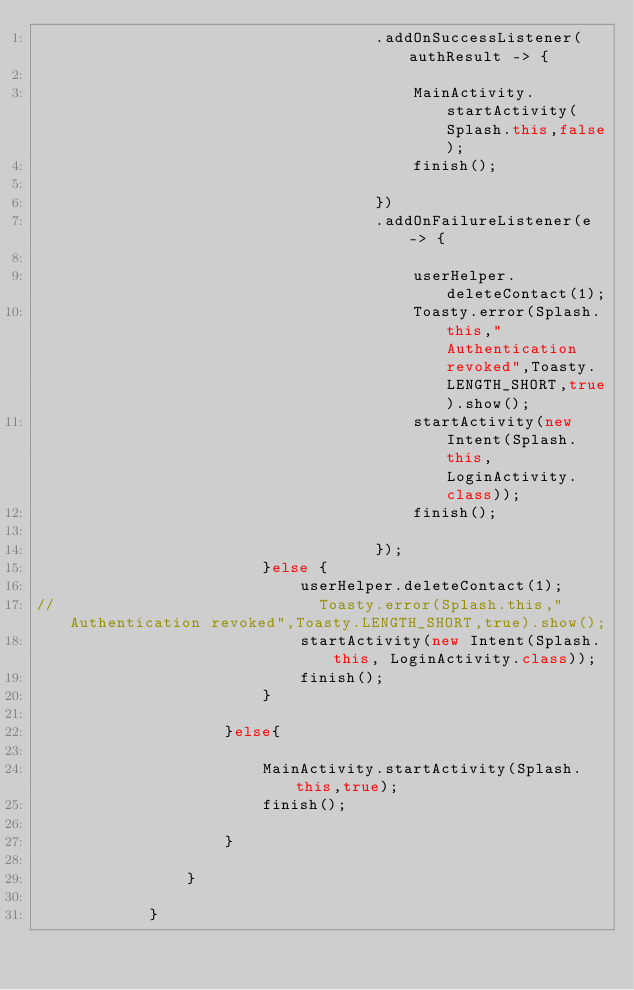<code> <loc_0><loc_0><loc_500><loc_500><_Java_>                                    .addOnSuccessListener(authResult -> {

                                        MainActivity.startActivity(Splash.this,false);
                                        finish();

                                    })
                                    .addOnFailureListener(e -> {

                                        userHelper.deleteContact(1);
                                        Toasty.error(Splash.this,"Authentication revoked",Toasty.LENGTH_SHORT,true).show();
                                        startActivity(new Intent(Splash.this, LoginActivity.class));
                                        finish();

                                    });
                        }else {
                            userHelper.deleteContact(1);
//                            Toasty.error(Splash.this,"Authentication revoked",Toasty.LENGTH_SHORT,true).show();
                            startActivity(new Intent(Splash.this, LoginActivity.class));
                            finish();
                        }

                    }else{

                        MainActivity.startActivity(Splash.this,true);
                        finish();

                    }

                }

            }</code> 